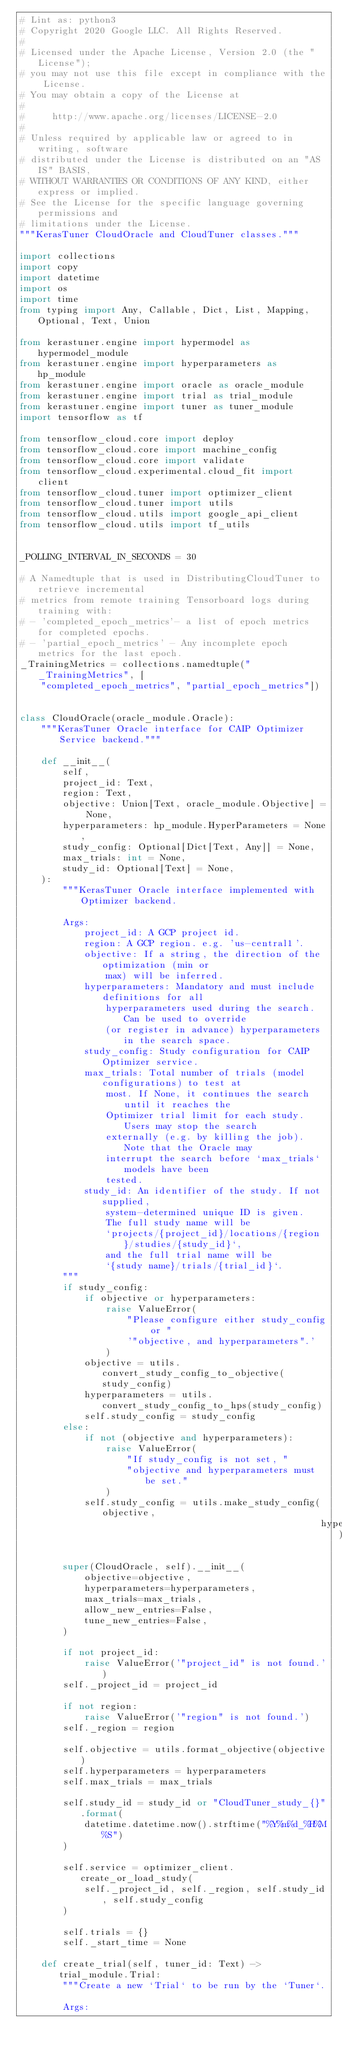Convert code to text. <code><loc_0><loc_0><loc_500><loc_500><_Python_># Lint as: python3
# Copyright 2020 Google LLC. All Rights Reserved.
#
# Licensed under the Apache License, Version 2.0 (the "License");
# you may not use this file except in compliance with the License.
# You may obtain a copy of the License at
#
#     http://www.apache.org/licenses/LICENSE-2.0
#
# Unless required by applicable law or agreed to in writing, software
# distributed under the License is distributed on an "AS IS" BASIS,
# WITHOUT WARRANTIES OR CONDITIONS OF ANY KIND, either express or implied.
# See the License for the specific language governing permissions and
# limitations under the License.
"""KerasTuner CloudOracle and CloudTuner classes."""

import collections
import copy
import datetime
import os
import time
from typing import Any, Callable, Dict, List, Mapping, Optional, Text, Union

from kerastuner.engine import hypermodel as hypermodel_module
from kerastuner.engine import hyperparameters as hp_module
from kerastuner.engine import oracle as oracle_module
from kerastuner.engine import trial as trial_module
from kerastuner.engine import tuner as tuner_module
import tensorflow as tf

from tensorflow_cloud.core import deploy
from tensorflow_cloud.core import machine_config
from tensorflow_cloud.core import validate
from tensorflow_cloud.experimental.cloud_fit import client
from tensorflow_cloud.tuner import optimizer_client
from tensorflow_cloud.tuner import utils
from tensorflow_cloud.utils import google_api_client
from tensorflow_cloud.utils import tf_utils


_POLLING_INTERVAL_IN_SECONDS = 30

# A Namedtuple that is used in DistributingCloudTuner to retrieve incremental
# metrics from remote training Tensorboard logs during training with:
# - 'completed_epoch_metrics'- a list of epoch metrics for completed epochs.
# - 'partial_epoch_metrics' - Any incomplete epoch metrics for the last epoch.
_TrainingMetrics = collections.namedtuple("_TrainingMetrics", [
    "completed_epoch_metrics", "partial_epoch_metrics"])


class CloudOracle(oracle_module.Oracle):
    """KerasTuner Oracle interface for CAIP Optimizer Service backend."""

    def __init__(
        self,
        project_id: Text,
        region: Text,
        objective: Union[Text, oracle_module.Objective] = None,
        hyperparameters: hp_module.HyperParameters = None,
        study_config: Optional[Dict[Text, Any]] = None,
        max_trials: int = None,
        study_id: Optional[Text] = None,
    ):
        """KerasTuner Oracle interface implemented with Optimizer backend.

        Args:
            project_id: A GCP project id.
            region: A GCP region. e.g. 'us-central1'.
            objective: If a string, the direction of the optimization (min or
                max) will be inferred.
            hyperparameters: Mandatory and must include definitions for all
                hyperparameters used during the search. Can be used to override
                (or register in advance) hyperparameters in the search space.
            study_config: Study configuration for CAIP Optimizer service.
            max_trials: Total number of trials (model configurations) to test at
                most. If None, it continues the search until it reaches the
                Optimizer trial limit for each study. Users may stop the search
                externally (e.g. by killing the job). Note that the Oracle may
                interrupt the search before `max_trials` models have been
                tested.
            study_id: An identifier of the study. If not supplied,
                system-determined unique ID is given.
                The full study name will be
                `projects/{project_id}/locations/{region}/studies/{study_id}`,
                and the full trial name will be
                `{study name}/trials/{trial_id}`.
        """
        if study_config:
            if objective or hyperparameters:
                raise ValueError(
                    "Please configure either study_config or "
                    '"objective, and hyperparameters".'
                )
            objective = utils.convert_study_config_to_objective(study_config)
            hyperparameters = utils.convert_study_config_to_hps(study_config)
            self.study_config = study_config
        else:
            if not (objective and hyperparameters):
                raise ValueError(
                    "If study_config is not set, "
                    "objective and hyperparameters must be set."
                )
            self.study_config = utils.make_study_config(objective,
                                                        hyperparameters)

        super(CloudOracle, self).__init__(
            objective=objective,
            hyperparameters=hyperparameters,
            max_trials=max_trials,
            allow_new_entries=False,
            tune_new_entries=False,
        )

        if not project_id:
            raise ValueError('"project_id" is not found.')
        self._project_id = project_id

        if not region:
            raise ValueError('"region" is not found.')
        self._region = region

        self.objective = utils.format_objective(objective)
        self.hyperparameters = hyperparameters
        self.max_trials = max_trials

        self.study_id = study_id or "CloudTuner_study_{}".format(
            datetime.datetime.now().strftime("%Y%m%d_%H%M%S")
        )

        self.service = optimizer_client.create_or_load_study(
            self._project_id, self._region, self.study_id, self.study_config
        )

        self.trials = {}
        self._start_time = None

    def create_trial(self, tuner_id: Text) -> trial_module.Trial:
        """Create a new `Trial` to be run by the `Tuner`.

        Args:</code> 